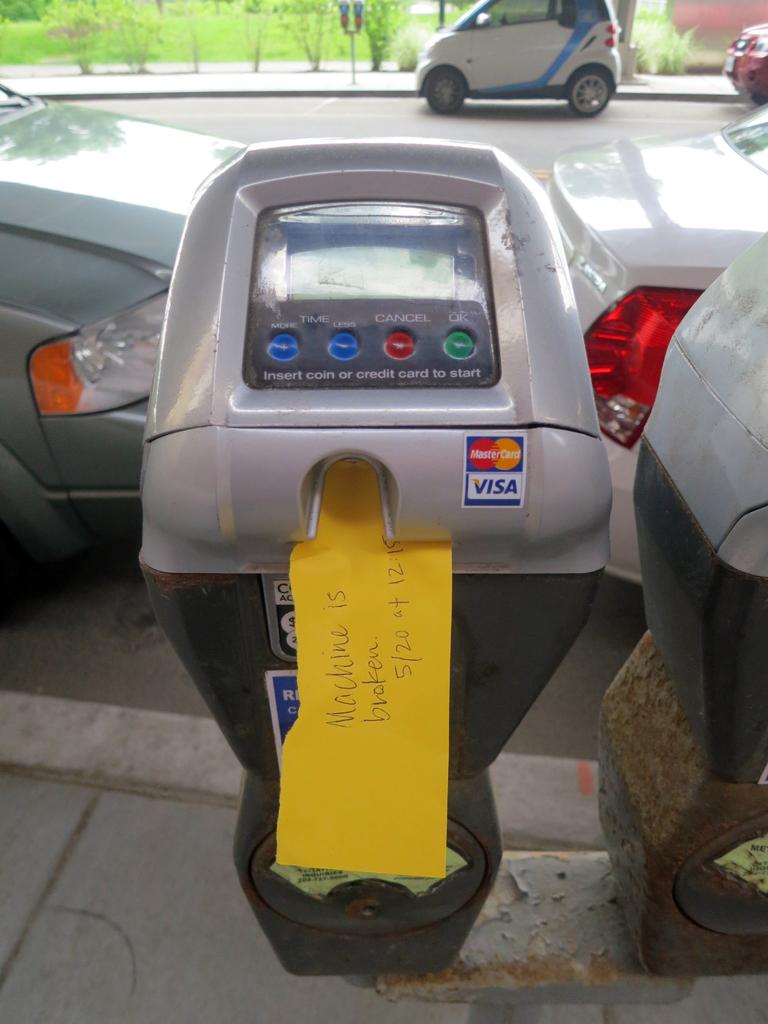Does this machine take visa?
Offer a terse response. Yes. Is it broken?
Give a very brief answer. Yes. 